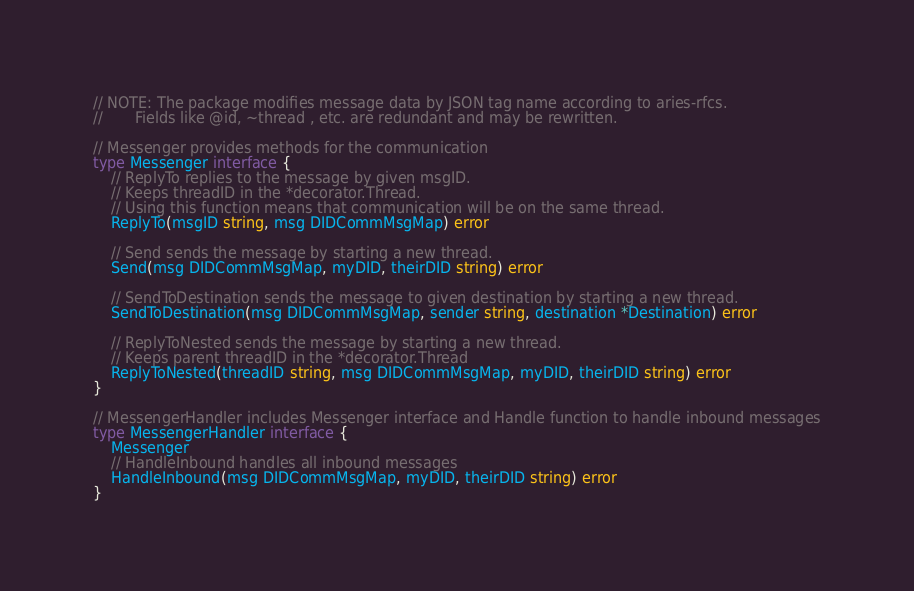Convert code to text. <code><loc_0><loc_0><loc_500><loc_500><_Go_>// NOTE: The package modifies message data by JSON tag name according to aries-rfcs.
//       Fields like @id, ~thread , etc. are redundant and may be rewritten.

// Messenger provides methods for the communication
type Messenger interface {
	// ReplyTo replies to the message by given msgID.
	// Keeps threadID in the *decorator.Thread.
	// Using this function means that communication will be on the same thread.
	ReplyTo(msgID string, msg DIDCommMsgMap) error

	// Send sends the message by starting a new thread.
	Send(msg DIDCommMsgMap, myDID, theirDID string) error

	// SendToDestination sends the message to given destination by starting a new thread.
	SendToDestination(msg DIDCommMsgMap, sender string, destination *Destination) error

	// ReplyToNested sends the message by starting a new thread.
	// Keeps parent threadID in the *decorator.Thread
	ReplyToNested(threadID string, msg DIDCommMsgMap, myDID, theirDID string) error
}

// MessengerHandler includes Messenger interface and Handle function to handle inbound messages
type MessengerHandler interface {
	Messenger
	// HandleInbound handles all inbound messages
	HandleInbound(msg DIDCommMsgMap, myDID, theirDID string) error
}
</code> 